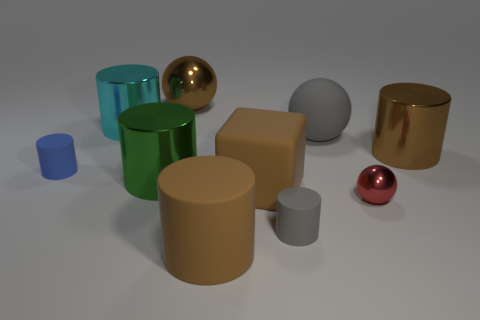Subtract all big brown cylinders. How many cylinders are left? 4 Subtract all gray spheres. How many spheres are left? 2 Subtract all gray balls. How many green cylinders are left? 1 Subtract all cubes. How many objects are left? 9 Subtract 1 cylinders. How many cylinders are left? 5 Subtract all purple blocks. Subtract all brown cylinders. How many blocks are left? 1 Subtract all tiny brown things. Subtract all brown matte cylinders. How many objects are left? 9 Add 8 big brown metallic things. How many big brown metallic things are left? 10 Add 8 large blue things. How many large blue things exist? 8 Subtract 0 red blocks. How many objects are left? 10 